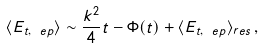Convert formula to latex. <formula><loc_0><loc_0><loc_500><loc_500>\langle E _ { t , \ e p } \rangle \sim \frac { k ^ { 2 } } { 4 } t - \Phi ( t ) + \langle E _ { t , \ e p } \rangle _ { r e s } \, ,</formula> 